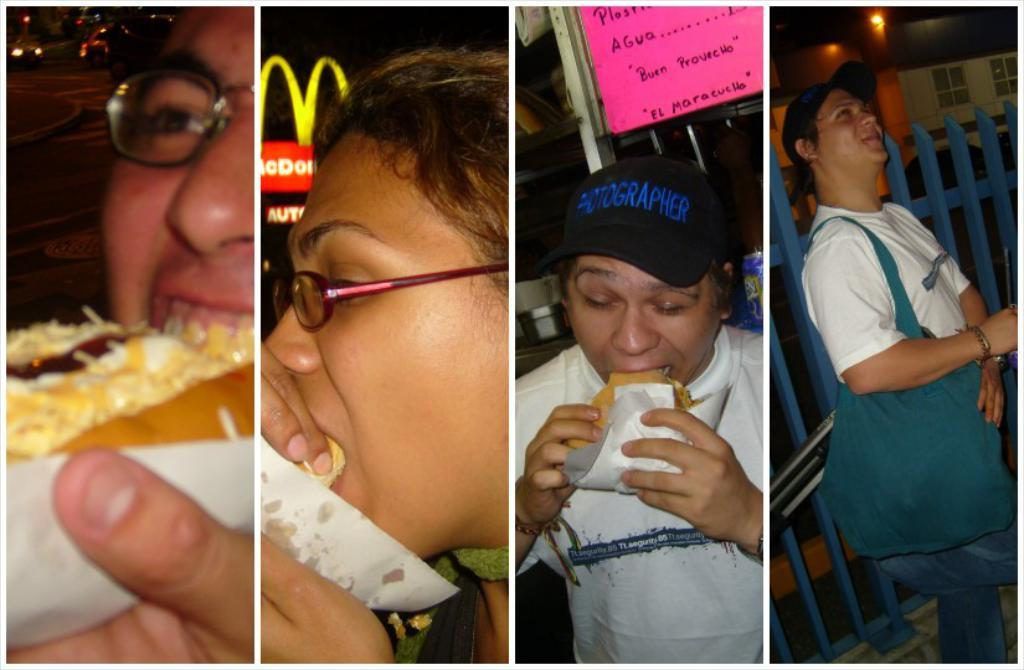How many people are in the image? There are three persons in the image. What are the persons doing in the image? The persons are eating food items. What can be seen in the background of the image? There is a logo, a board attached to a pole, a building, a light, a fence, and a wall in the background of the image. What type of vessel is being used to extinguish the flame in the image? There is no vessel or flame present in the image. What unit of measurement is used to determine the height of the wall in the image? The image does not provide information about the height of the wall or any unit of measurement. 